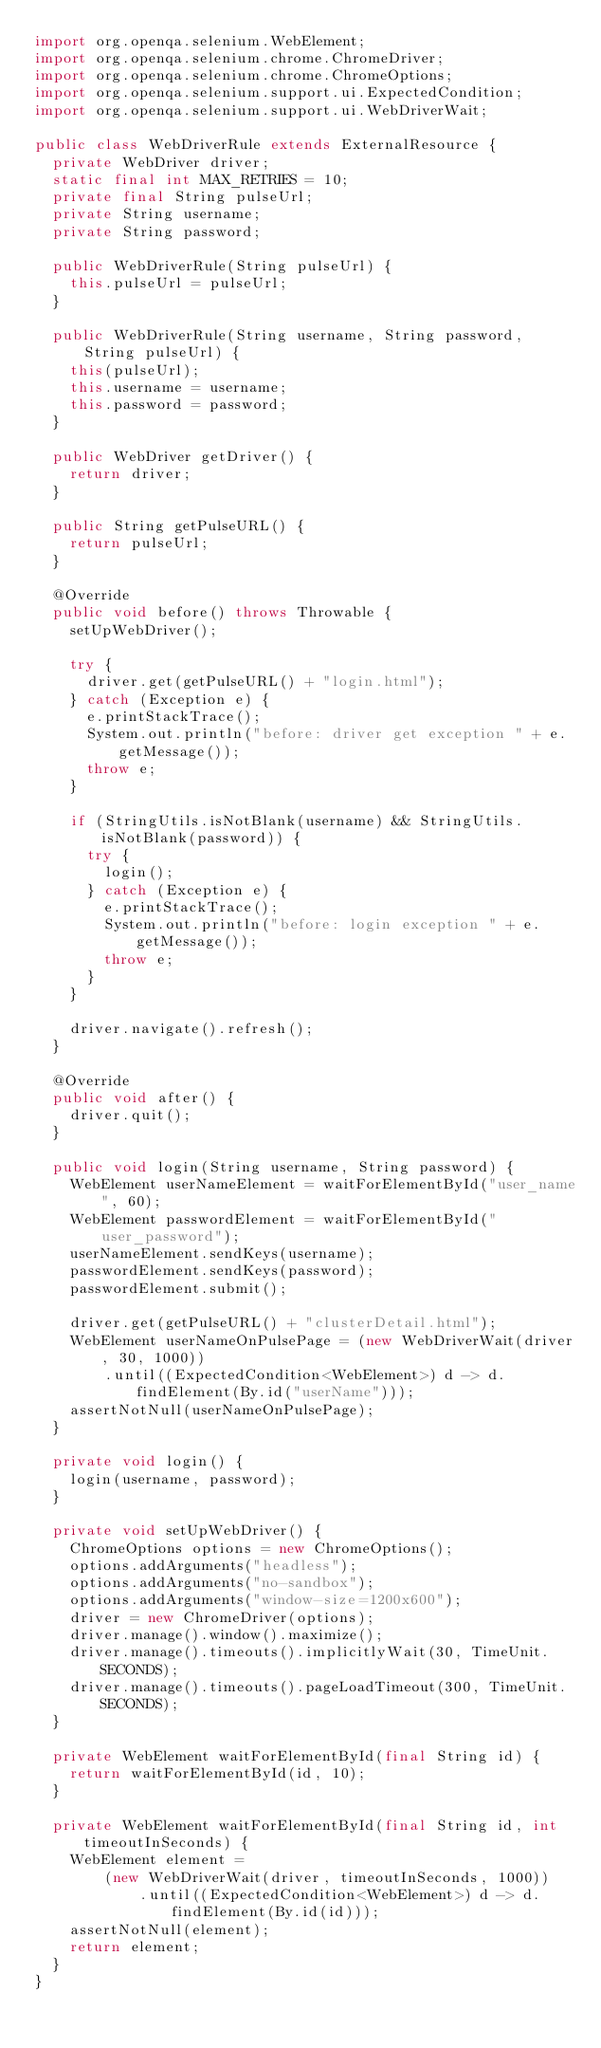<code> <loc_0><loc_0><loc_500><loc_500><_Java_>import org.openqa.selenium.WebElement;
import org.openqa.selenium.chrome.ChromeDriver;
import org.openqa.selenium.chrome.ChromeOptions;
import org.openqa.selenium.support.ui.ExpectedCondition;
import org.openqa.selenium.support.ui.WebDriverWait;

public class WebDriverRule extends ExternalResource {
  private WebDriver driver;
  static final int MAX_RETRIES = 10;
  private final String pulseUrl;
  private String username;
  private String password;

  public WebDriverRule(String pulseUrl) {
    this.pulseUrl = pulseUrl;
  }

  public WebDriverRule(String username, String password, String pulseUrl) {
    this(pulseUrl);
    this.username = username;
    this.password = password;
  }

  public WebDriver getDriver() {
    return driver;
  }

  public String getPulseURL() {
    return pulseUrl;
  }

  @Override
  public void before() throws Throwable {
    setUpWebDriver();

    try {
      driver.get(getPulseURL() + "login.html");
    } catch (Exception e) {
      e.printStackTrace();
      System.out.println("before: driver get exception " + e.getMessage());
      throw e;
    }

    if (StringUtils.isNotBlank(username) && StringUtils.isNotBlank(password)) {
      try {
        login();
      } catch (Exception e) {
        e.printStackTrace();
        System.out.println("before: login exception " + e.getMessage());
        throw e;
      }
    }

    driver.navigate().refresh();
  }

  @Override
  public void after() {
    driver.quit();
  }

  public void login(String username, String password) {
    WebElement userNameElement = waitForElementById("user_name", 60);
    WebElement passwordElement = waitForElementById("user_password");
    userNameElement.sendKeys(username);
    passwordElement.sendKeys(password);
    passwordElement.submit();

    driver.get(getPulseURL() + "clusterDetail.html");
    WebElement userNameOnPulsePage = (new WebDriverWait(driver, 30, 1000))
        .until((ExpectedCondition<WebElement>) d -> d.findElement(By.id("userName")));
    assertNotNull(userNameOnPulsePage);
  }

  private void login() {
    login(username, password);
  }

  private void setUpWebDriver() {
    ChromeOptions options = new ChromeOptions();
    options.addArguments("headless");
    options.addArguments("no-sandbox");
    options.addArguments("window-size=1200x600");
    driver = new ChromeDriver(options);
    driver.manage().window().maximize();
    driver.manage().timeouts().implicitlyWait(30, TimeUnit.SECONDS);
    driver.manage().timeouts().pageLoadTimeout(300, TimeUnit.SECONDS);
  }

  private WebElement waitForElementById(final String id) {
    return waitForElementById(id, 10);
  }

  private WebElement waitForElementById(final String id, int timeoutInSeconds) {
    WebElement element =
        (new WebDriverWait(driver, timeoutInSeconds, 1000))
            .until((ExpectedCondition<WebElement>) d -> d.findElement(By.id(id)));
    assertNotNull(element);
    return element;
  }
}
</code> 